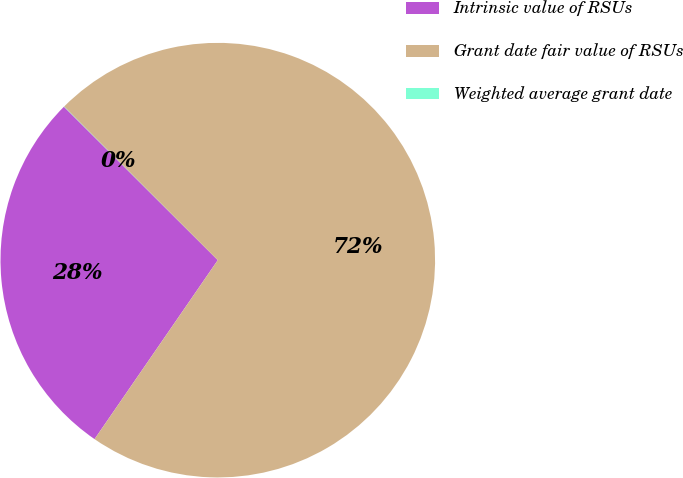Convert chart. <chart><loc_0><loc_0><loc_500><loc_500><pie_chart><fcel>Intrinsic value of RSUs<fcel>Grant date fair value of RSUs<fcel>Weighted average grant date<nl><fcel>27.88%<fcel>72.1%<fcel>0.02%<nl></chart> 